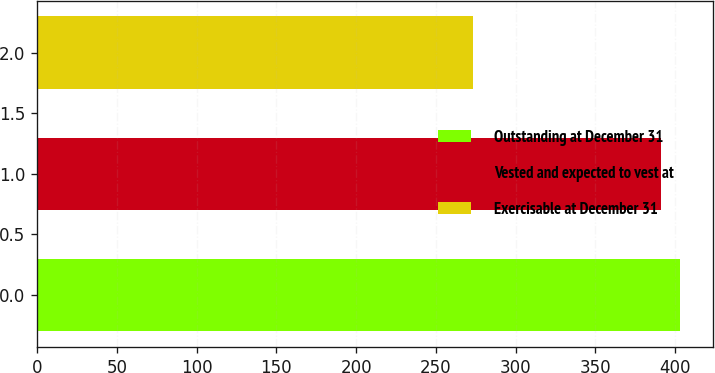<chart> <loc_0><loc_0><loc_500><loc_500><bar_chart><fcel>Outstanding at December 31<fcel>Vested and expected to vest at<fcel>Exercisable at December 31<nl><fcel>403.3<fcel>391<fcel>273<nl></chart> 